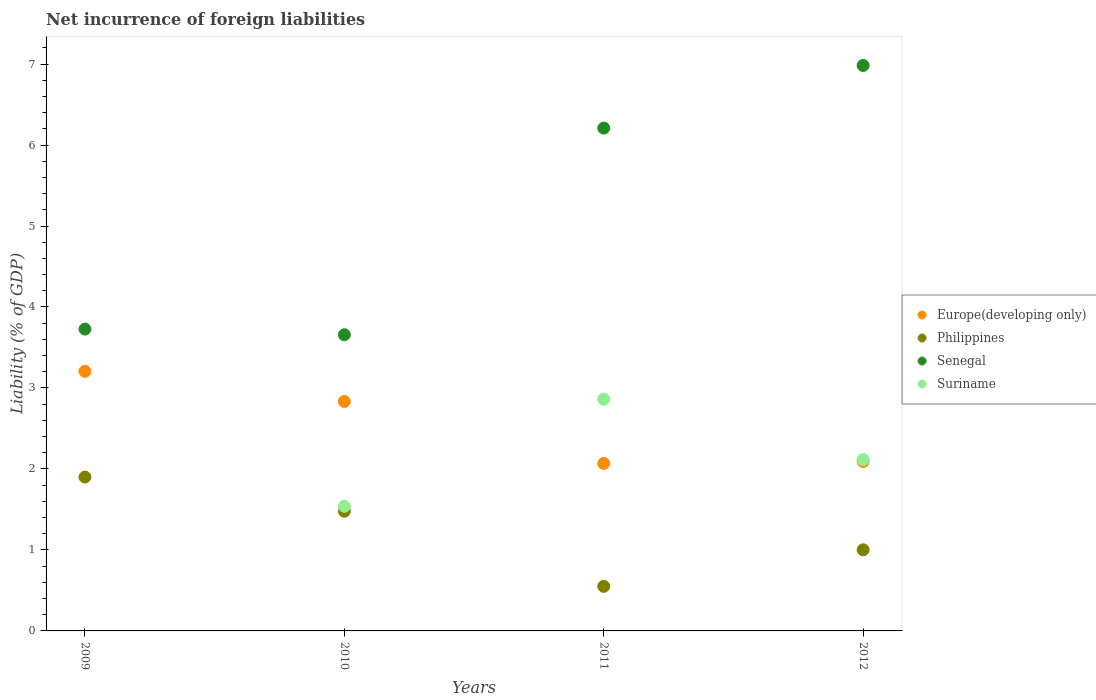How many different coloured dotlines are there?
Ensure brevity in your answer.  4. Is the number of dotlines equal to the number of legend labels?
Your response must be concise. No. What is the net incurrence of foreign liabilities in Senegal in 2012?
Provide a short and direct response. 6.98. Across all years, what is the maximum net incurrence of foreign liabilities in Europe(developing only)?
Give a very brief answer. 3.21. Across all years, what is the minimum net incurrence of foreign liabilities in Philippines?
Your answer should be compact. 0.55. What is the total net incurrence of foreign liabilities in Europe(developing only) in the graph?
Provide a succinct answer. 10.2. What is the difference between the net incurrence of foreign liabilities in Suriname in 2010 and that in 2012?
Keep it short and to the point. -0.58. What is the difference between the net incurrence of foreign liabilities in Europe(developing only) in 2010 and the net incurrence of foreign liabilities in Philippines in 2012?
Your response must be concise. 1.83. What is the average net incurrence of foreign liabilities in Suriname per year?
Offer a very short reply. 1.63. In the year 2009, what is the difference between the net incurrence of foreign liabilities in Philippines and net incurrence of foreign liabilities in Senegal?
Make the answer very short. -1.83. What is the ratio of the net incurrence of foreign liabilities in Europe(developing only) in 2009 to that in 2012?
Keep it short and to the point. 1.53. What is the difference between the highest and the second highest net incurrence of foreign liabilities in Europe(developing only)?
Give a very brief answer. 0.37. What is the difference between the highest and the lowest net incurrence of foreign liabilities in Senegal?
Your answer should be very brief. 3.33. Is the sum of the net incurrence of foreign liabilities in Europe(developing only) in 2009 and 2011 greater than the maximum net incurrence of foreign liabilities in Senegal across all years?
Provide a succinct answer. No. Does the net incurrence of foreign liabilities in Suriname monotonically increase over the years?
Ensure brevity in your answer.  No. Is the net incurrence of foreign liabilities in Senegal strictly greater than the net incurrence of foreign liabilities in Philippines over the years?
Provide a short and direct response. Yes. Is the net incurrence of foreign liabilities in Philippines strictly less than the net incurrence of foreign liabilities in Suriname over the years?
Keep it short and to the point. No. How many dotlines are there?
Ensure brevity in your answer.  4. Are the values on the major ticks of Y-axis written in scientific E-notation?
Provide a short and direct response. No. Does the graph contain grids?
Offer a terse response. No. Where does the legend appear in the graph?
Give a very brief answer. Center right. What is the title of the graph?
Make the answer very short. Net incurrence of foreign liabilities. What is the label or title of the Y-axis?
Your answer should be very brief. Liability (% of GDP). What is the Liability (% of GDP) of Europe(developing only) in 2009?
Give a very brief answer. 3.21. What is the Liability (% of GDP) in Philippines in 2009?
Offer a very short reply. 1.9. What is the Liability (% of GDP) in Senegal in 2009?
Your response must be concise. 3.73. What is the Liability (% of GDP) of Suriname in 2009?
Provide a short and direct response. 0. What is the Liability (% of GDP) of Europe(developing only) in 2010?
Offer a terse response. 2.83. What is the Liability (% of GDP) in Philippines in 2010?
Provide a succinct answer. 1.48. What is the Liability (% of GDP) in Senegal in 2010?
Your answer should be compact. 3.66. What is the Liability (% of GDP) of Suriname in 2010?
Offer a very short reply. 1.54. What is the Liability (% of GDP) of Europe(developing only) in 2011?
Your answer should be compact. 2.07. What is the Liability (% of GDP) of Philippines in 2011?
Offer a very short reply. 0.55. What is the Liability (% of GDP) of Senegal in 2011?
Your answer should be compact. 6.21. What is the Liability (% of GDP) of Suriname in 2011?
Provide a short and direct response. 2.86. What is the Liability (% of GDP) in Europe(developing only) in 2012?
Give a very brief answer. 2.09. What is the Liability (% of GDP) of Philippines in 2012?
Provide a short and direct response. 1. What is the Liability (% of GDP) in Senegal in 2012?
Make the answer very short. 6.98. What is the Liability (% of GDP) of Suriname in 2012?
Your answer should be compact. 2.12. Across all years, what is the maximum Liability (% of GDP) of Europe(developing only)?
Provide a short and direct response. 3.21. Across all years, what is the maximum Liability (% of GDP) of Philippines?
Keep it short and to the point. 1.9. Across all years, what is the maximum Liability (% of GDP) of Senegal?
Make the answer very short. 6.98. Across all years, what is the maximum Liability (% of GDP) in Suriname?
Offer a very short reply. 2.86. Across all years, what is the minimum Liability (% of GDP) in Europe(developing only)?
Offer a terse response. 2.07. Across all years, what is the minimum Liability (% of GDP) of Philippines?
Your answer should be compact. 0.55. Across all years, what is the minimum Liability (% of GDP) of Senegal?
Offer a very short reply. 3.66. Across all years, what is the minimum Liability (% of GDP) of Suriname?
Ensure brevity in your answer.  0. What is the total Liability (% of GDP) in Europe(developing only) in the graph?
Offer a terse response. 10.2. What is the total Liability (% of GDP) in Philippines in the graph?
Your answer should be compact. 4.93. What is the total Liability (% of GDP) of Senegal in the graph?
Ensure brevity in your answer.  20.58. What is the total Liability (% of GDP) in Suriname in the graph?
Your answer should be very brief. 6.52. What is the difference between the Liability (% of GDP) in Europe(developing only) in 2009 and that in 2010?
Provide a short and direct response. 0.37. What is the difference between the Liability (% of GDP) of Philippines in 2009 and that in 2010?
Your answer should be compact. 0.42. What is the difference between the Liability (% of GDP) of Senegal in 2009 and that in 2010?
Keep it short and to the point. 0.07. What is the difference between the Liability (% of GDP) in Europe(developing only) in 2009 and that in 2011?
Ensure brevity in your answer.  1.14. What is the difference between the Liability (% of GDP) of Philippines in 2009 and that in 2011?
Provide a succinct answer. 1.35. What is the difference between the Liability (% of GDP) of Senegal in 2009 and that in 2011?
Provide a succinct answer. -2.48. What is the difference between the Liability (% of GDP) in Europe(developing only) in 2009 and that in 2012?
Your response must be concise. 1.11. What is the difference between the Liability (% of GDP) in Philippines in 2009 and that in 2012?
Provide a short and direct response. 0.9. What is the difference between the Liability (% of GDP) of Senegal in 2009 and that in 2012?
Ensure brevity in your answer.  -3.26. What is the difference between the Liability (% of GDP) of Europe(developing only) in 2010 and that in 2011?
Offer a very short reply. 0.77. What is the difference between the Liability (% of GDP) of Philippines in 2010 and that in 2011?
Ensure brevity in your answer.  0.93. What is the difference between the Liability (% of GDP) of Senegal in 2010 and that in 2011?
Your answer should be compact. -2.55. What is the difference between the Liability (% of GDP) in Suriname in 2010 and that in 2011?
Keep it short and to the point. -1.32. What is the difference between the Liability (% of GDP) of Europe(developing only) in 2010 and that in 2012?
Offer a terse response. 0.74. What is the difference between the Liability (% of GDP) of Philippines in 2010 and that in 2012?
Make the answer very short. 0.48. What is the difference between the Liability (% of GDP) in Senegal in 2010 and that in 2012?
Your answer should be very brief. -3.33. What is the difference between the Liability (% of GDP) in Suriname in 2010 and that in 2012?
Make the answer very short. -0.58. What is the difference between the Liability (% of GDP) in Europe(developing only) in 2011 and that in 2012?
Ensure brevity in your answer.  -0.02. What is the difference between the Liability (% of GDP) in Philippines in 2011 and that in 2012?
Provide a succinct answer. -0.45. What is the difference between the Liability (% of GDP) of Senegal in 2011 and that in 2012?
Your answer should be compact. -0.77. What is the difference between the Liability (% of GDP) in Suriname in 2011 and that in 2012?
Provide a short and direct response. 0.75. What is the difference between the Liability (% of GDP) in Europe(developing only) in 2009 and the Liability (% of GDP) in Philippines in 2010?
Provide a short and direct response. 1.73. What is the difference between the Liability (% of GDP) in Europe(developing only) in 2009 and the Liability (% of GDP) in Senegal in 2010?
Your response must be concise. -0.45. What is the difference between the Liability (% of GDP) in Europe(developing only) in 2009 and the Liability (% of GDP) in Suriname in 2010?
Provide a short and direct response. 1.67. What is the difference between the Liability (% of GDP) of Philippines in 2009 and the Liability (% of GDP) of Senegal in 2010?
Keep it short and to the point. -1.76. What is the difference between the Liability (% of GDP) in Philippines in 2009 and the Liability (% of GDP) in Suriname in 2010?
Your answer should be very brief. 0.36. What is the difference between the Liability (% of GDP) in Senegal in 2009 and the Liability (% of GDP) in Suriname in 2010?
Your answer should be very brief. 2.19. What is the difference between the Liability (% of GDP) of Europe(developing only) in 2009 and the Liability (% of GDP) of Philippines in 2011?
Offer a terse response. 2.66. What is the difference between the Liability (% of GDP) of Europe(developing only) in 2009 and the Liability (% of GDP) of Senegal in 2011?
Offer a terse response. -3. What is the difference between the Liability (% of GDP) in Europe(developing only) in 2009 and the Liability (% of GDP) in Suriname in 2011?
Your answer should be very brief. 0.34. What is the difference between the Liability (% of GDP) of Philippines in 2009 and the Liability (% of GDP) of Senegal in 2011?
Provide a short and direct response. -4.31. What is the difference between the Liability (% of GDP) in Philippines in 2009 and the Liability (% of GDP) in Suriname in 2011?
Make the answer very short. -0.96. What is the difference between the Liability (% of GDP) in Senegal in 2009 and the Liability (% of GDP) in Suriname in 2011?
Your answer should be very brief. 0.87. What is the difference between the Liability (% of GDP) of Europe(developing only) in 2009 and the Liability (% of GDP) of Philippines in 2012?
Give a very brief answer. 2.2. What is the difference between the Liability (% of GDP) of Europe(developing only) in 2009 and the Liability (% of GDP) of Senegal in 2012?
Offer a terse response. -3.78. What is the difference between the Liability (% of GDP) in Europe(developing only) in 2009 and the Liability (% of GDP) in Suriname in 2012?
Offer a very short reply. 1.09. What is the difference between the Liability (% of GDP) in Philippines in 2009 and the Liability (% of GDP) in Senegal in 2012?
Ensure brevity in your answer.  -5.08. What is the difference between the Liability (% of GDP) in Philippines in 2009 and the Liability (% of GDP) in Suriname in 2012?
Your answer should be compact. -0.22. What is the difference between the Liability (% of GDP) of Senegal in 2009 and the Liability (% of GDP) of Suriname in 2012?
Your answer should be compact. 1.61. What is the difference between the Liability (% of GDP) of Europe(developing only) in 2010 and the Liability (% of GDP) of Philippines in 2011?
Make the answer very short. 2.28. What is the difference between the Liability (% of GDP) in Europe(developing only) in 2010 and the Liability (% of GDP) in Senegal in 2011?
Ensure brevity in your answer.  -3.38. What is the difference between the Liability (% of GDP) in Europe(developing only) in 2010 and the Liability (% of GDP) in Suriname in 2011?
Your answer should be very brief. -0.03. What is the difference between the Liability (% of GDP) in Philippines in 2010 and the Liability (% of GDP) in Senegal in 2011?
Provide a short and direct response. -4.73. What is the difference between the Liability (% of GDP) in Philippines in 2010 and the Liability (% of GDP) in Suriname in 2011?
Offer a terse response. -1.38. What is the difference between the Liability (% of GDP) of Senegal in 2010 and the Liability (% of GDP) of Suriname in 2011?
Your answer should be very brief. 0.8. What is the difference between the Liability (% of GDP) in Europe(developing only) in 2010 and the Liability (% of GDP) in Philippines in 2012?
Offer a terse response. 1.83. What is the difference between the Liability (% of GDP) of Europe(developing only) in 2010 and the Liability (% of GDP) of Senegal in 2012?
Make the answer very short. -4.15. What is the difference between the Liability (% of GDP) in Europe(developing only) in 2010 and the Liability (% of GDP) in Suriname in 2012?
Offer a very short reply. 0.72. What is the difference between the Liability (% of GDP) of Philippines in 2010 and the Liability (% of GDP) of Senegal in 2012?
Provide a short and direct response. -5.5. What is the difference between the Liability (% of GDP) in Philippines in 2010 and the Liability (% of GDP) in Suriname in 2012?
Make the answer very short. -0.64. What is the difference between the Liability (% of GDP) in Senegal in 2010 and the Liability (% of GDP) in Suriname in 2012?
Provide a succinct answer. 1.54. What is the difference between the Liability (% of GDP) of Europe(developing only) in 2011 and the Liability (% of GDP) of Philippines in 2012?
Offer a terse response. 1.07. What is the difference between the Liability (% of GDP) of Europe(developing only) in 2011 and the Liability (% of GDP) of Senegal in 2012?
Your answer should be compact. -4.91. What is the difference between the Liability (% of GDP) in Europe(developing only) in 2011 and the Liability (% of GDP) in Suriname in 2012?
Make the answer very short. -0.05. What is the difference between the Liability (% of GDP) of Philippines in 2011 and the Liability (% of GDP) of Senegal in 2012?
Offer a very short reply. -6.43. What is the difference between the Liability (% of GDP) of Philippines in 2011 and the Liability (% of GDP) of Suriname in 2012?
Give a very brief answer. -1.56. What is the difference between the Liability (% of GDP) of Senegal in 2011 and the Liability (% of GDP) of Suriname in 2012?
Keep it short and to the point. 4.09. What is the average Liability (% of GDP) in Europe(developing only) per year?
Keep it short and to the point. 2.55. What is the average Liability (% of GDP) in Philippines per year?
Your answer should be very brief. 1.23. What is the average Liability (% of GDP) in Senegal per year?
Offer a terse response. 5.14. What is the average Liability (% of GDP) in Suriname per year?
Your response must be concise. 1.63. In the year 2009, what is the difference between the Liability (% of GDP) of Europe(developing only) and Liability (% of GDP) of Philippines?
Provide a succinct answer. 1.31. In the year 2009, what is the difference between the Liability (% of GDP) of Europe(developing only) and Liability (% of GDP) of Senegal?
Offer a terse response. -0.52. In the year 2009, what is the difference between the Liability (% of GDP) of Philippines and Liability (% of GDP) of Senegal?
Give a very brief answer. -1.83. In the year 2010, what is the difference between the Liability (% of GDP) in Europe(developing only) and Liability (% of GDP) in Philippines?
Give a very brief answer. 1.36. In the year 2010, what is the difference between the Liability (% of GDP) of Europe(developing only) and Liability (% of GDP) of Senegal?
Provide a succinct answer. -0.82. In the year 2010, what is the difference between the Liability (% of GDP) of Europe(developing only) and Liability (% of GDP) of Suriname?
Give a very brief answer. 1.3. In the year 2010, what is the difference between the Liability (% of GDP) of Philippines and Liability (% of GDP) of Senegal?
Give a very brief answer. -2.18. In the year 2010, what is the difference between the Liability (% of GDP) of Philippines and Liability (% of GDP) of Suriname?
Make the answer very short. -0.06. In the year 2010, what is the difference between the Liability (% of GDP) of Senegal and Liability (% of GDP) of Suriname?
Provide a succinct answer. 2.12. In the year 2011, what is the difference between the Liability (% of GDP) in Europe(developing only) and Liability (% of GDP) in Philippines?
Keep it short and to the point. 1.52. In the year 2011, what is the difference between the Liability (% of GDP) of Europe(developing only) and Liability (% of GDP) of Senegal?
Provide a short and direct response. -4.14. In the year 2011, what is the difference between the Liability (% of GDP) of Europe(developing only) and Liability (% of GDP) of Suriname?
Provide a succinct answer. -0.79. In the year 2011, what is the difference between the Liability (% of GDP) of Philippines and Liability (% of GDP) of Senegal?
Ensure brevity in your answer.  -5.66. In the year 2011, what is the difference between the Liability (% of GDP) of Philippines and Liability (% of GDP) of Suriname?
Ensure brevity in your answer.  -2.31. In the year 2011, what is the difference between the Liability (% of GDP) in Senegal and Liability (% of GDP) in Suriname?
Your answer should be very brief. 3.35. In the year 2012, what is the difference between the Liability (% of GDP) in Europe(developing only) and Liability (% of GDP) in Philippines?
Your answer should be very brief. 1.09. In the year 2012, what is the difference between the Liability (% of GDP) in Europe(developing only) and Liability (% of GDP) in Senegal?
Your answer should be compact. -4.89. In the year 2012, what is the difference between the Liability (% of GDP) in Europe(developing only) and Liability (% of GDP) in Suriname?
Your answer should be very brief. -0.02. In the year 2012, what is the difference between the Liability (% of GDP) in Philippines and Liability (% of GDP) in Senegal?
Make the answer very short. -5.98. In the year 2012, what is the difference between the Liability (% of GDP) in Philippines and Liability (% of GDP) in Suriname?
Provide a short and direct response. -1.11. In the year 2012, what is the difference between the Liability (% of GDP) of Senegal and Liability (% of GDP) of Suriname?
Your answer should be very brief. 4.87. What is the ratio of the Liability (% of GDP) of Europe(developing only) in 2009 to that in 2010?
Give a very brief answer. 1.13. What is the ratio of the Liability (% of GDP) of Philippines in 2009 to that in 2010?
Keep it short and to the point. 1.29. What is the ratio of the Liability (% of GDP) in Senegal in 2009 to that in 2010?
Your answer should be very brief. 1.02. What is the ratio of the Liability (% of GDP) in Europe(developing only) in 2009 to that in 2011?
Your answer should be very brief. 1.55. What is the ratio of the Liability (% of GDP) in Philippines in 2009 to that in 2011?
Keep it short and to the point. 3.45. What is the ratio of the Liability (% of GDP) of Senegal in 2009 to that in 2011?
Provide a succinct answer. 0.6. What is the ratio of the Liability (% of GDP) in Europe(developing only) in 2009 to that in 2012?
Your answer should be compact. 1.53. What is the ratio of the Liability (% of GDP) of Philippines in 2009 to that in 2012?
Ensure brevity in your answer.  1.9. What is the ratio of the Liability (% of GDP) in Senegal in 2009 to that in 2012?
Keep it short and to the point. 0.53. What is the ratio of the Liability (% of GDP) in Europe(developing only) in 2010 to that in 2011?
Your answer should be very brief. 1.37. What is the ratio of the Liability (% of GDP) in Philippines in 2010 to that in 2011?
Ensure brevity in your answer.  2.68. What is the ratio of the Liability (% of GDP) in Senegal in 2010 to that in 2011?
Offer a terse response. 0.59. What is the ratio of the Liability (% of GDP) in Suriname in 2010 to that in 2011?
Give a very brief answer. 0.54. What is the ratio of the Liability (% of GDP) in Europe(developing only) in 2010 to that in 2012?
Offer a very short reply. 1.35. What is the ratio of the Liability (% of GDP) in Philippines in 2010 to that in 2012?
Ensure brevity in your answer.  1.48. What is the ratio of the Liability (% of GDP) in Senegal in 2010 to that in 2012?
Your answer should be compact. 0.52. What is the ratio of the Liability (% of GDP) in Suriname in 2010 to that in 2012?
Offer a terse response. 0.73. What is the ratio of the Liability (% of GDP) in Europe(developing only) in 2011 to that in 2012?
Your answer should be very brief. 0.99. What is the ratio of the Liability (% of GDP) in Philippines in 2011 to that in 2012?
Your answer should be very brief. 0.55. What is the ratio of the Liability (% of GDP) of Senegal in 2011 to that in 2012?
Offer a terse response. 0.89. What is the ratio of the Liability (% of GDP) in Suriname in 2011 to that in 2012?
Your response must be concise. 1.35. What is the difference between the highest and the second highest Liability (% of GDP) in Europe(developing only)?
Ensure brevity in your answer.  0.37. What is the difference between the highest and the second highest Liability (% of GDP) of Philippines?
Provide a short and direct response. 0.42. What is the difference between the highest and the second highest Liability (% of GDP) in Senegal?
Your answer should be compact. 0.77. What is the difference between the highest and the second highest Liability (% of GDP) in Suriname?
Provide a short and direct response. 0.75. What is the difference between the highest and the lowest Liability (% of GDP) of Europe(developing only)?
Keep it short and to the point. 1.14. What is the difference between the highest and the lowest Liability (% of GDP) in Philippines?
Offer a terse response. 1.35. What is the difference between the highest and the lowest Liability (% of GDP) in Senegal?
Give a very brief answer. 3.33. What is the difference between the highest and the lowest Liability (% of GDP) in Suriname?
Provide a short and direct response. 2.86. 